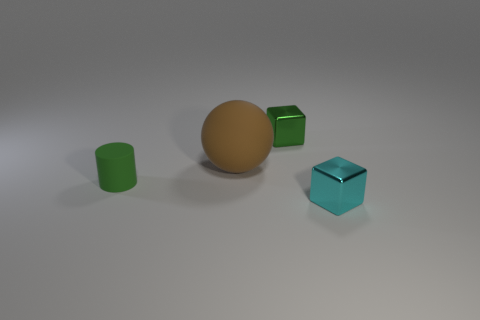Is the number of small green shiny cubes less than the number of gray matte spheres?
Your response must be concise. No. Do the tiny metal object in front of the small green metallic thing and the metallic thing that is behind the small cyan metal thing have the same shape?
Your response must be concise. Yes. What is the color of the big sphere?
Offer a very short reply. Brown. What number of rubber objects are either cyan spheres or cyan things?
Provide a succinct answer. 0. There is another small object that is the same shape as the cyan object; what is its color?
Offer a terse response. Green. Is there a large brown object?
Make the answer very short. Yes. Does the green object to the right of the cylinder have the same material as the thing on the left side of the sphere?
Your answer should be very brief. No. There is a tiny metal object that is the same color as the rubber cylinder; what is its shape?
Offer a terse response. Cube. What number of things are objects that are on the right side of the large thing or small cyan objects in front of the green shiny block?
Keep it short and to the point. 2. Do the tiny block behind the sphere and the object that is in front of the green matte cylinder have the same color?
Offer a very short reply. No. 